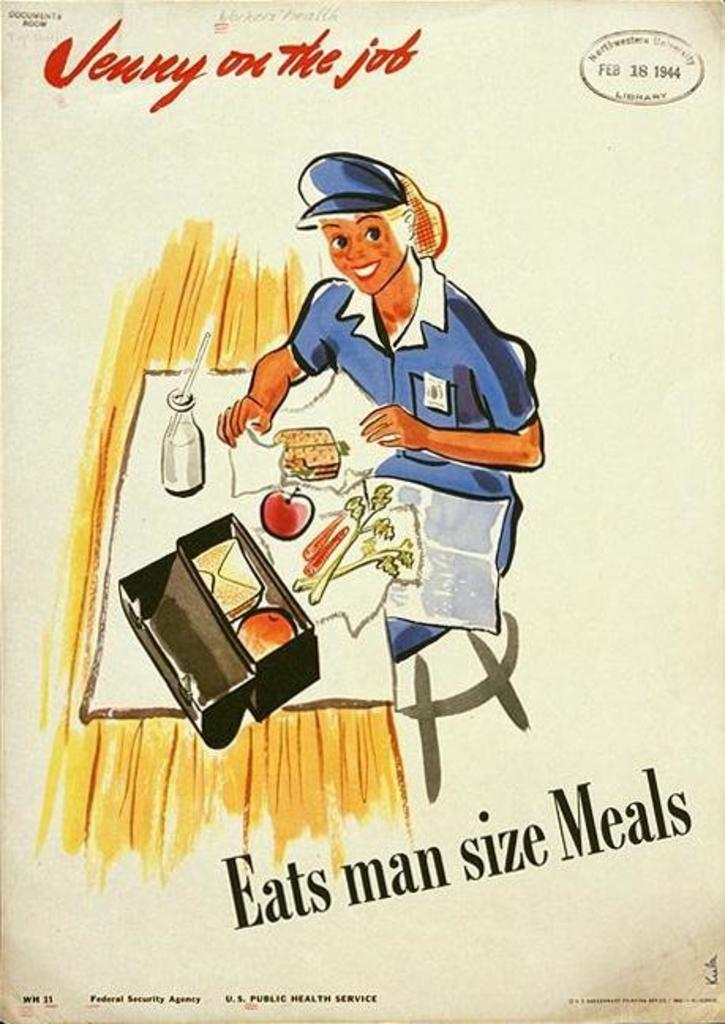<image>
Share a concise interpretation of the image provided. an ad with a woman on it that says eats man size meals 